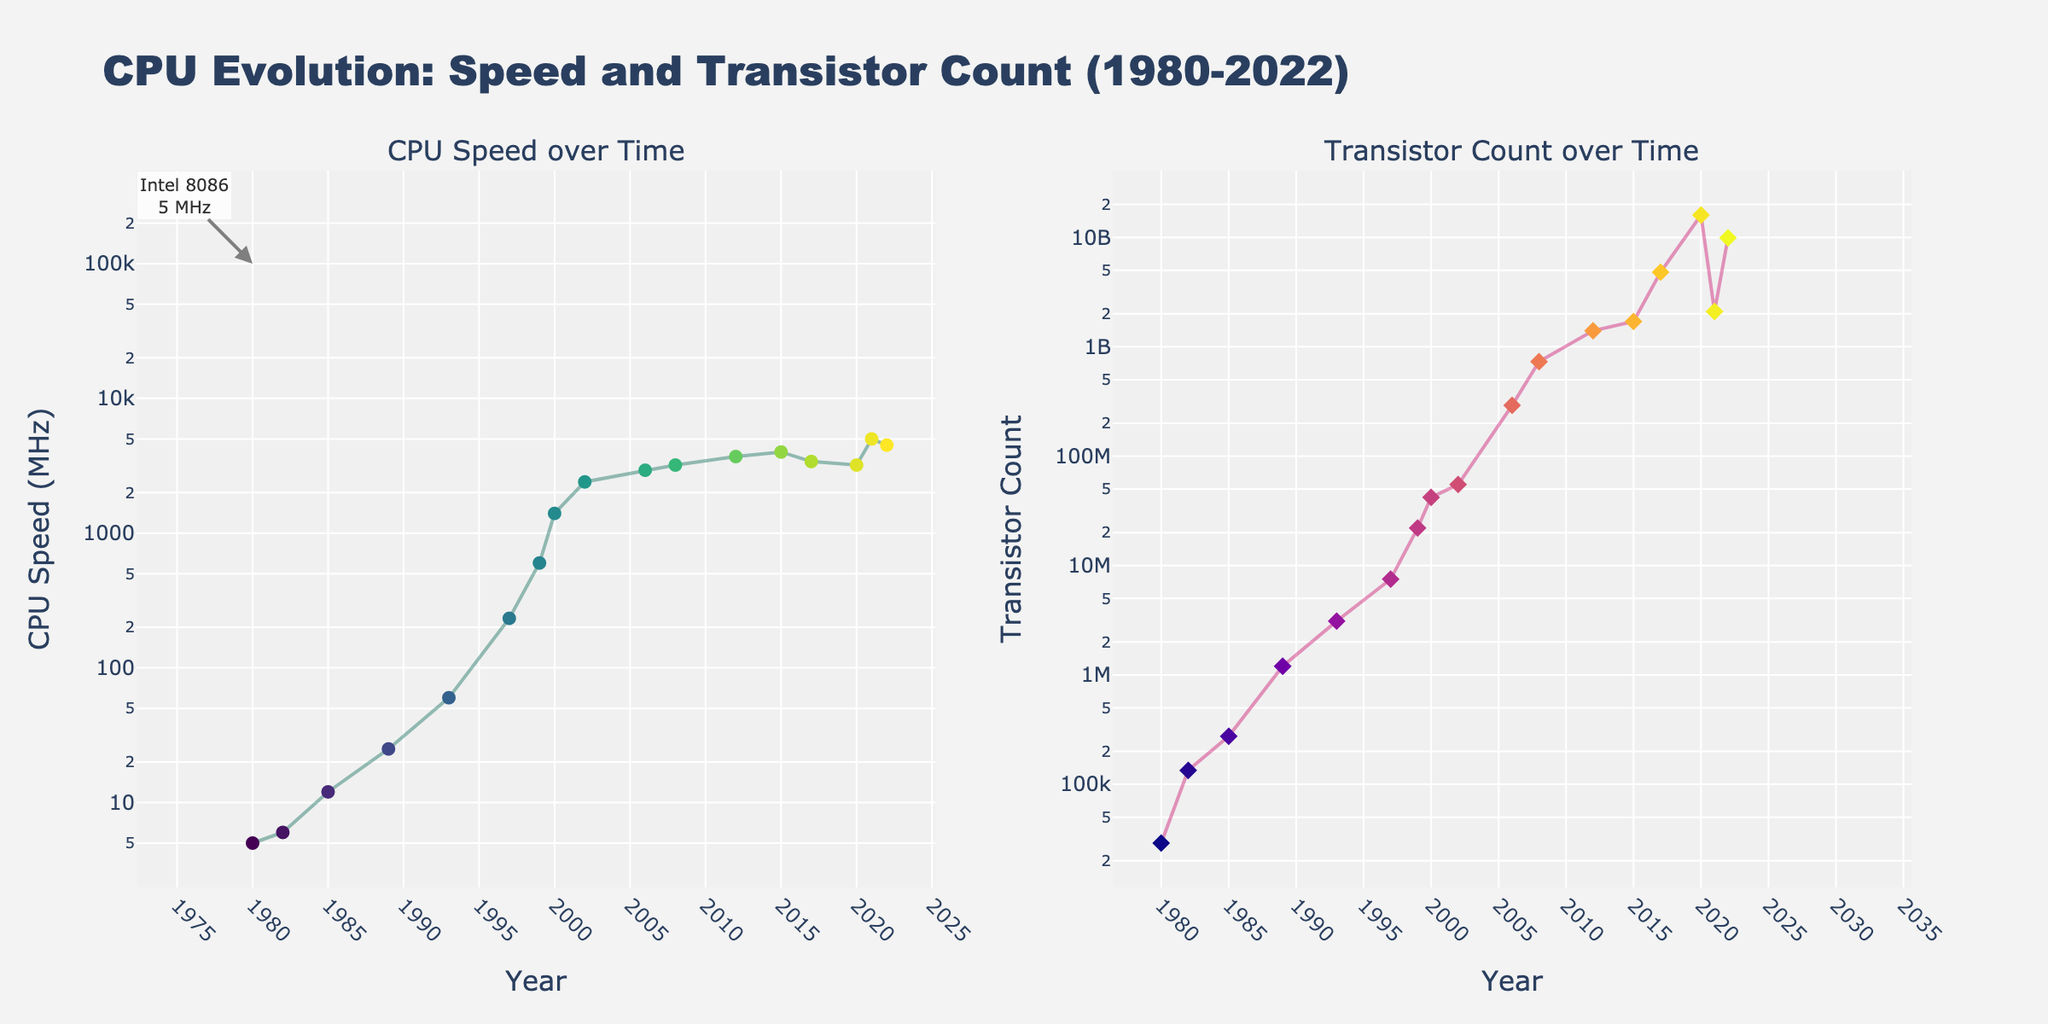What is the title of the figure? The title of the figure is located at the top center. It reads "CPU Evolution: Speed and Transistor Count (1980-2022)".
Answer: CPU Evolution: Speed and Transistor Count (1980-2022) How many years of data are displayed in the figure? By counting the number of distinct year ticks on the x-axis of either subplot, we can determine that there are data points from 1980 to 2022.
Answer: 17 Which subplot contains the data for CPU Speed? The subplot on the left-hand side has the y-axis labeled "CPU Speed (MHz)", indicating that it contains the CPU Speed data.
Answer: The left subplot What is the highest CPU Speed (MHz) recorded, and in which year and model? The highest point on the CPU Speed subplot appears around 5000 MHz in the year 2021 for the Intel Core i9 (Alder Lake), which is annotated.
Answer: 5000 MHz, Intel Core i9 (Alder Lake), 2021 What is the shape and color used for markers in the Transistor Count subplot? The markers for Transistor Count are diamond-shaped and colored in a range of hues from the 'Plasma' colorscale.
Answer: Diamond shape, 'Plasma' colorscale Which CPU model had the highest transistor count, and what is that count? The annotation on the right subplot indicates that the Apple M1 in 2020 has the highest transistor count. The count is 16,000,000,000 transistors.
Answer: Apple M1, 16,000,000,000 transistors What's the difference in CPU Speed between the Intel 8086 (1980) and Intel Core i9 (Alder Lake) (2021)? The Intel 8086 had a speed of 5 MHz while the Intel Core i9 (Alder Lake) had 5000 MHz. The difference is 5000 - 5 = 4995 MHz.
Answer: 4995 MHz How has the number of transistors changed from the Intel Pentium 4 in 2000 to the Apple M1 in 2020? The Intel Pentium 4 in 2000 has 42,000,000 transistors, and the Apple M1 in 2020 has 16,000,000,000 transistors. The change is 16,000,000,000 - 42,000,000 = 15,958,000,000.
Answer: 15,958,000,000 increase How many CPU models are shown in the figure? Each data point represents a unique CPU model as labeled in the figure. There are 17 distinct data points, hence 17 CPU models.
Answer: 17 Is there a correlation between CPU Speed and Transistor Count over the years? Observing both subplots, we see that as the Transistor Count increases, so does the CPU Speed, indicating a positive correlation.
Answer: Yes 